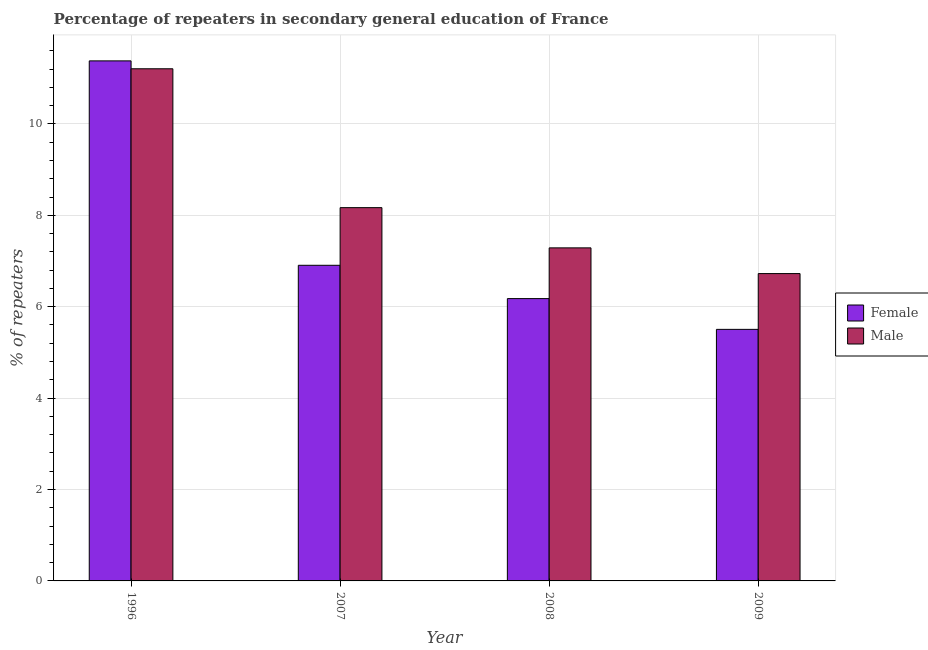How many different coloured bars are there?
Your response must be concise. 2. How many groups of bars are there?
Give a very brief answer. 4. Are the number of bars per tick equal to the number of legend labels?
Offer a terse response. Yes. How many bars are there on the 2nd tick from the left?
Provide a succinct answer. 2. What is the label of the 1st group of bars from the left?
Give a very brief answer. 1996. What is the percentage of female repeaters in 2008?
Offer a terse response. 6.18. Across all years, what is the maximum percentage of female repeaters?
Make the answer very short. 11.38. Across all years, what is the minimum percentage of male repeaters?
Your answer should be compact. 6.72. In which year was the percentage of male repeaters maximum?
Provide a succinct answer. 1996. In which year was the percentage of female repeaters minimum?
Your answer should be compact. 2009. What is the total percentage of male repeaters in the graph?
Provide a short and direct response. 33.39. What is the difference between the percentage of male repeaters in 1996 and that in 2009?
Make the answer very short. 4.48. What is the difference between the percentage of female repeaters in 2009 and the percentage of male repeaters in 1996?
Offer a very short reply. -5.87. What is the average percentage of male repeaters per year?
Your response must be concise. 8.35. In how many years, is the percentage of male repeaters greater than 1.6 %?
Offer a terse response. 4. What is the ratio of the percentage of female repeaters in 2008 to that in 2009?
Give a very brief answer. 1.12. Is the difference between the percentage of female repeaters in 1996 and 2008 greater than the difference between the percentage of male repeaters in 1996 and 2008?
Your response must be concise. No. What is the difference between the highest and the second highest percentage of female repeaters?
Make the answer very short. 4.47. What is the difference between the highest and the lowest percentage of female repeaters?
Provide a short and direct response. 5.87. In how many years, is the percentage of female repeaters greater than the average percentage of female repeaters taken over all years?
Ensure brevity in your answer.  1. Is the sum of the percentage of female repeaters in 1996 and 2007 greater than the maximum percentage of male repeaters across all years?
Make the answer very short. Yes. What does the 2nd bar from the left in 2007 represents?
Provide a succinct answer. Male. What does the 2nd bar from the right in 2007 represents?
Provide a short and direct response. Female. How many bars are there?
Offer a very short reply. 8. How many years are there in the graph?
Offer a very short reply. 4. Are the values on the major ticks of Y-axis written in scientific E-notation?
Make the answer very short. No. Does the graph contain any zero values?
Give a very brief answer. No. Does the graph contain grids?
Offer a terse response. Yes. Where does the legend appear in the graph?
Give a very brief answer. Center right. What is the title of the graph?
Make the answer very short. Percentage of repeaters in secondary general education of France. Does "Taxes on profits and capital gains" appear as one of the legend labels in the graph?
Your answer should be compact. No. What is the label or title of the Y-axis?
Your response must be concise. % of repeaters. What is the % of repeaters of Female in 1996?
Your response must be concise. 11.38. What is the % of repeaters of Male in 1996?
Your answer should be very brief. 11.21. What is the % of repeaters of Female in 2007?
Ensure brevity in your answer.  6.91. What is the % of repeaters in Male in 2007?
Provide a short and direct response. 8.17. What is the % of repeaters in Female in 2008?
Your answer should be compact. 6.18. What is the % of repeaters of Male in 2008?
Keep it short and to the point. 7.29. What is the % of repeaters of Female in 2009?
Make the answer very short. 5.5. What is the % of repeaters in Male in 2009?
Ensure brevity in your answer.  6.72. Across all years, what is the maximum % of repeaters in Female?
Your answer should be compact. 11.38. Across all years, what is the maximum % of repeaters in Male?
Provide a short and direct response. 11.21. Across all years, what is the minimum % of repeaters in Female?
Make the answer very short. 5.5. Across all years, what is the minimum % of repeaters in Male?
Offer a very short reply. 6.72. What is the total % of repeaters in Female in the graph?
Your answer should be very brief. 29.97. What is the total % of repeaters in Male in the graph?
Ensure brevity in your answer.  33.39. What is the difference between the % of repeaters in Female in 1996 and that in 2007?
Offer a terse response. 4.47. What is the difference between the % of repeaters of Male in 1996 and that in 2007?
Give a very brief answer. 3.04. What is the difference between the % of repeaters of Female in 1996 and that in 2008?
Provide a succinct answer. 5.2. What is the difference between the % of repeaters in Male in 1996 and that in 2008?
Give a very brief answer. 3.92. What is the difference between the % of repeaters of Female in 1996 and that in 2009?
Your response must be concise. 5.87. What is the difference between the % of repeaters of Male in 1996 and that in 2009?
Your response must be concise. 4.48. What is the difference between the % of repeaters in Female in 2007 and that in 2008?
Make the answer very short. 0.73. What is the difference between the % of repeaters of Male in 2007 and that in 2008?
Your answer should be compact. 0.88. What is the difference between the % of repeaters of Female in 2007 and that in 2009?
Your answer should be compact. 1.4. What is the difference between the % of repeaters in Male in 2007 and that in 2009?
Keep it short and to the point. 1.44. What is the difference between the % of repeaters of Female in 2008 and that in 2009?
Offer a terse response. 0.67. What is the difference between the % of repeaters of Male in 2008 and that in 2009?
Keep it short and to the point. 0.56. What is the difference between the % of repeaters of Female in 1996 and the % of repeaters of Male in 2007?
Provide a succinct answer. 3.21. What is the difference between the % of repeaters in Female in 1996 and the % of repeaters in Male in 2008?
Your response must be concise. 4.09. What is the difference between the % of repeaters of Female in 1996 and the % of repeaters of Male in 2009?
Provide a short and direct response. 4.65. What is the difference between the % of repeaters of Female in 2007 and the % of repeaters of Male in 2008?
Ensure brevity in your answer.  -0.38. What is the difference between the % of repeaters of Female in 2007 and the % of repeaters of Male in 2009?
Offer a very short reply. 0.18. What is the difference between the % of repeaters of Female in 2008 and the % of repeaters of Male in 2009?
Offer a terse response. -0.55. What is the average % of repeaters in Female per year?
Your answer should be very brief. 7.49. What is the average % of repeaters in Male per year?
Offer a terse response. 8.35. In the year 1996, what is the difference between the % of repeaters of Female and % of repeaters of Male?
Your answer should be compact. 0.17. In the year 2007, what is the difference between the % of repeaters of Female and % of repeaters of Male?
Give a very brief answer. -1.26. In the year 2008, what is the difference between the % of repeaters in Female and % of repeaters in Male?
Offer a very short reply. -1.11. In the year 2009, what is the difference between the % of repeaters of Female and % of repeaters of Male?
Make the answer very short. -1.22. What is the ratio of the % of repeaters of Female in 1996 to that in 2007?
Offer a very short reply. 1.65. What is the ratio of the % of repeaters in Male in 1996 to that in 2007?
Your response must be concise. 1.37. What is the ratio of the % of repeaters in Female in 1996 to that in 2008?
Provide a short and direct response. 1.84. What is the ratio of the % of repeaters of Male in 1996 to that in 2008?
Your response must be concise. 1.54. What is the ratio of the % of repeaters of Female in 1996 to that in 2009?
Ensure brevity in your answer.  2.07. What is the ratio of the % of repeaters in Male in 1996 to that in 2009?
Make the answer very short. 1.67. What is the ratio of the % of repeaters in Female in 2007 to that in 2008?
Offer a terse response. 1.12. What is the ratio of the % of repeaters in Male in 2007 to that in 2008?
Offer a terse response. 1.12. What is the ratio of the % of repeaters in Female in 2007 to that in 2009?
Your answer should be very brief. 1.25. What is the ratio of the % of repeaters of Male in 2007 to that in 2009?
Keep it short and to the point. 1.21. What is the ratio of the % of repeaters of Female in 2008 to that in 2009?
Your answer should be compact. 1.12. What is the ratio of the % of repeaters in Male in 2008 to that in 2009?
Offer a terse response. 1.08. What is the difference between the highest and the second highest % of repeaters in Female?
Your answer should be compact. 4.47. What is the difference between the highest and the second highest % of repeaters in Male?
Offer a very short reply. 3.04. What is the difference between the highest and the lowest % of repeaters of Female?
Provide a short and direct response. 5.87. What is the difference between the highest and the lowest % of repeaters of Male?
Your response must be concise. 4.48. 